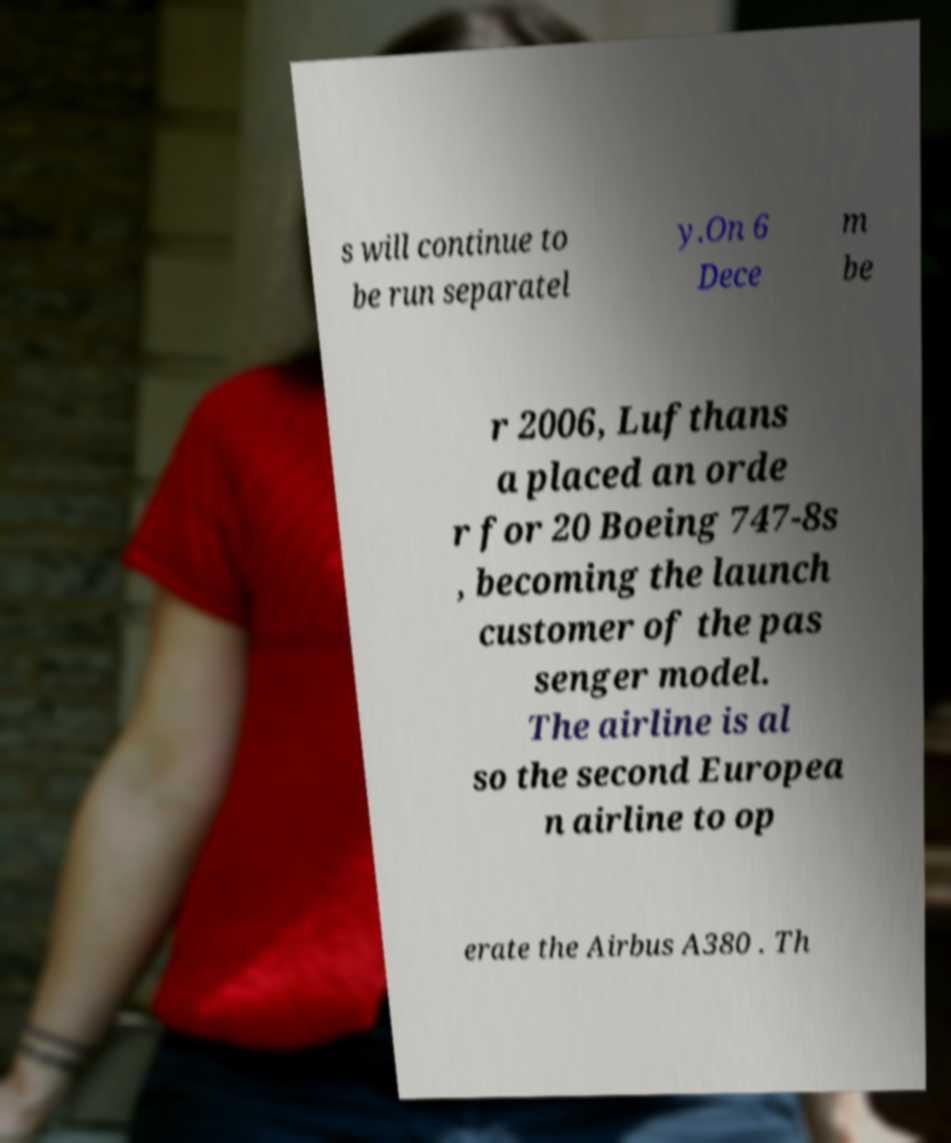Could you assist in decoding the text presented in this image and type it out clearly? s will continue to be run separatel y.On 6 Dece m be r 2006, Lufthans a placed an orde r for 20 Boeing 747-8s , becoming the launch customer of the pas senger model. The airline is al so the second Europea n airline to op erate the Airbus A380 . Th 